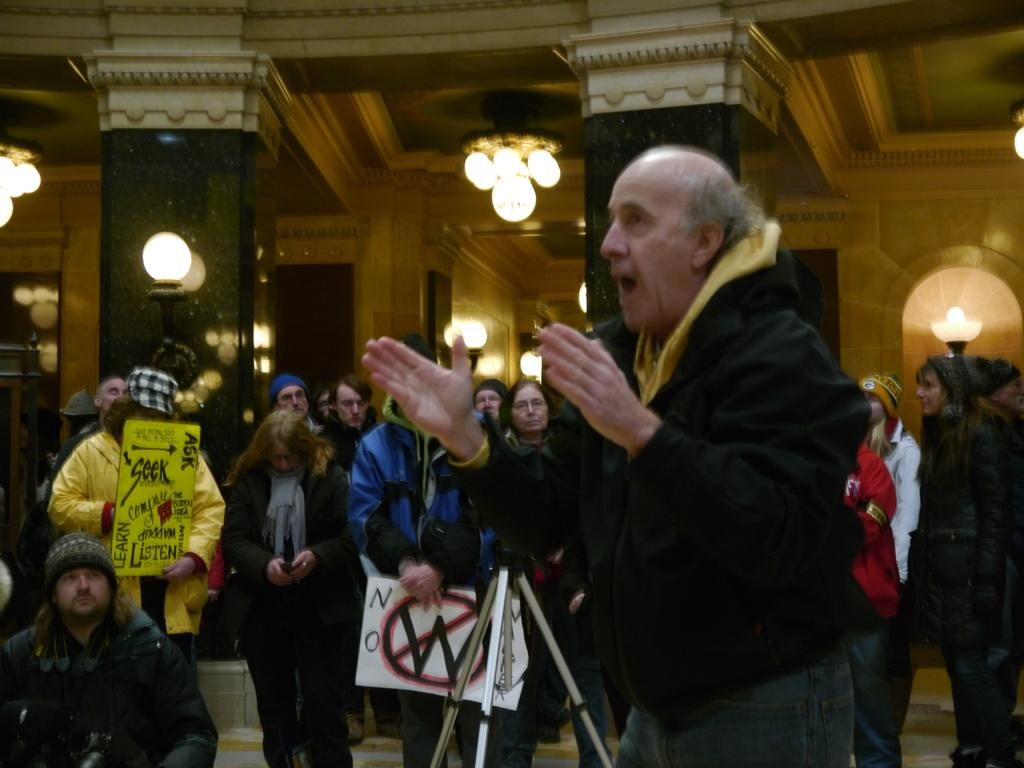How many people are present in the image? There are many people in the image. What are some of the people holding in the image? Some people are holding posters with text and pictures. What can be seen in the background of the image? There are pillars, lights, and a wall in the background of the image. What type of notebook is being used by the person holding a spoon and ice in the image? There is no person holding a spoon and ice in the image, and therefore no notebook can be associated with such an action. 